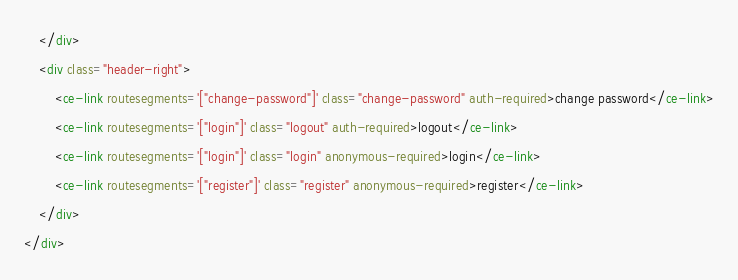Convert code to text. <code><loc_0><loc_0><loc_500><loc_500><_HTML_>    </div>
    <div class="header-right">
        <ce-link routesegments='["change-password"]' class="change-password" auth-required>change password</ce-link>
        <ce-link routesegments='["login"]' class="logout" auth-required>logout</ce-link>
        <ce-link routesegments='["login"]' class="login" anonymous-required>login</ce-link>        
        <ce-link routesegments='["register"]' class="register" anonymous-required>register</ce-link>
    </div>
</div>

</code> 